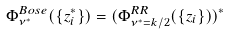<formula> <loc_0><loc_0><loc_500><loc_500>\Phi ^ { B o s e } _ { \nu ^ { * } } ( \{ z _ { i } ^ { * } \} ) = ( \Phi ^ { R R } _ { \nu ^ { * } = k / 2 } ( \{ z _ { i } \} ) ) ^ { * }</formula> 